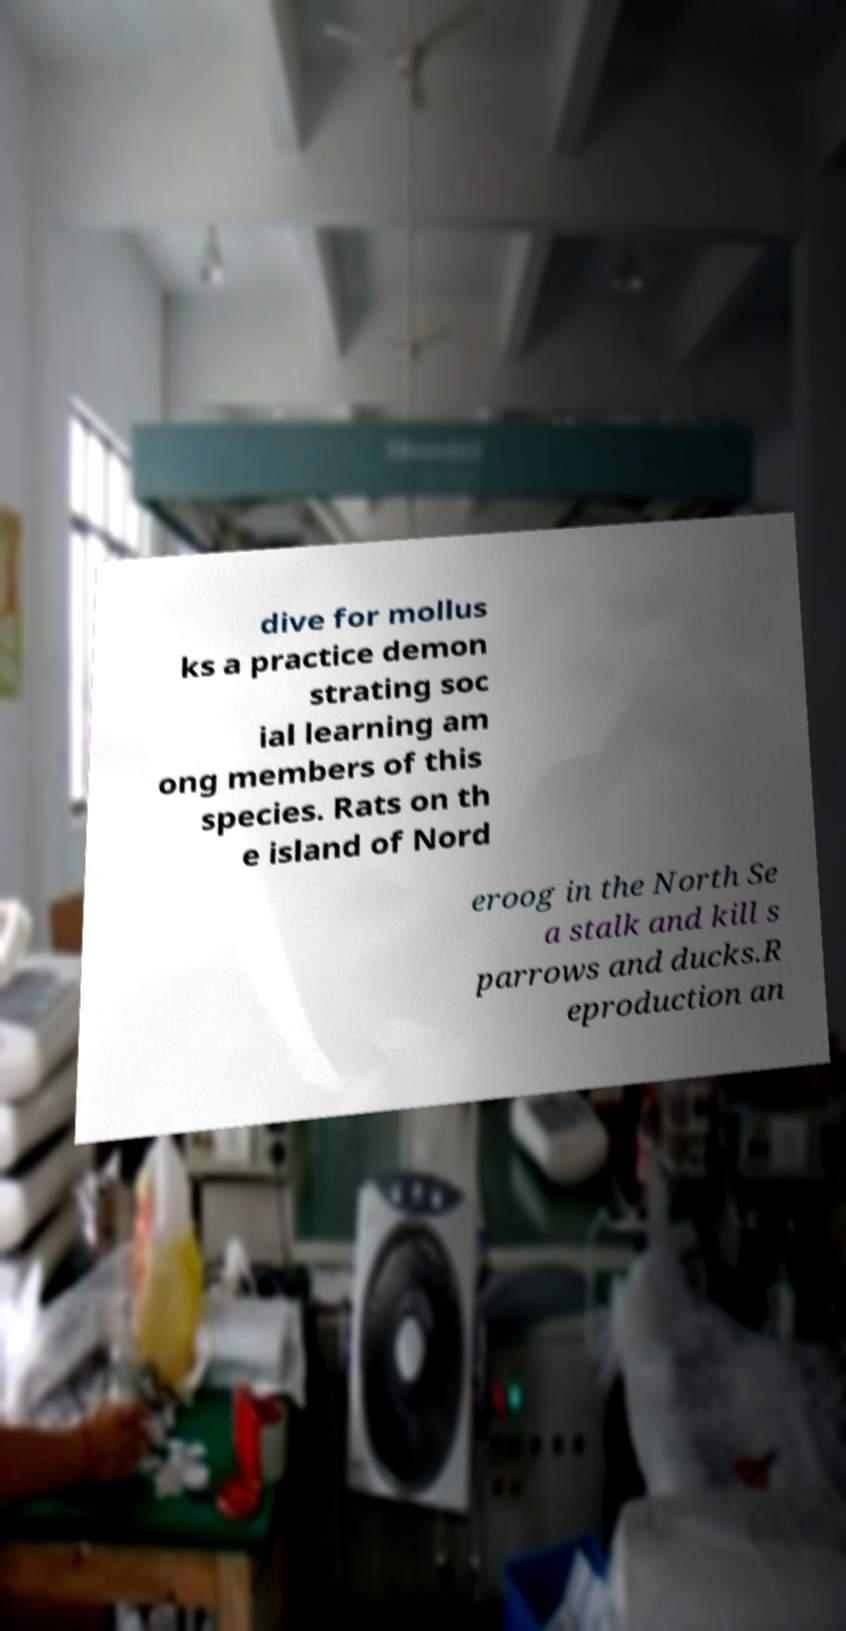Could you assist in decoding the text presented in this image and type it out clearly? dive for mollus ks a practice demon strating soc ial learning am ong members of this species. Rats on th e island of Nord eroog in the North Se a stalk and kill s parrows and ducks.R eproduction an 